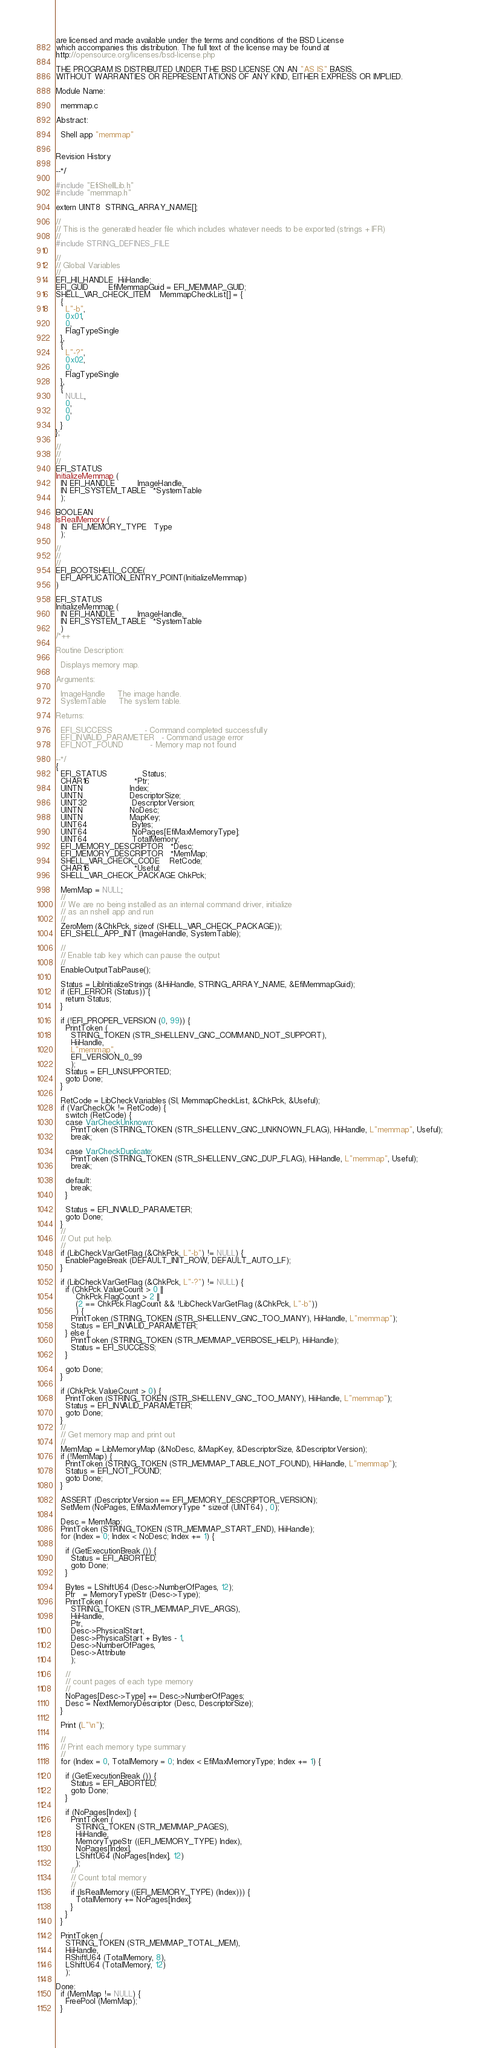Convert code to text. <code><loc_0><loc_0><loc_500><loc_500><_C_>are licensed and made available under the terms and conditions of the BSD License         
which accompanies this distribution. The full text of the license may be found at         
http://opensource.org/licenses/bsd-license.php                                            
                                                                                          
THE PROGRAM IS DISTRIBUTED UNDER THE BSD LICENSE ON AN "AS IS" BASIS,                     
WITHOUT WARRANTIES OR REPRESENTATIONS OF ANY KIND, EITHER EXPRESS OR IMPLIED.             

Module Name: 

  memmap.c
  
Abstract:

  Shell app "memmap"


Revision History

--*/

#include "EfiShellLib.h"
#include "memmap.h"

extern UINT8  STRING_ARRAY_NAME[];

//
// This is the generated header file which includes whatever needs to be exported (strings + IFR)
//
#include STRING_DEFINES_FILE

//
// Global Variables
//
EFI_HII_HANDLE  HiiHandle;
EFI_GUID        EfiMemmapGuid = EFI_MEMMAP_GUID;
SHELL_VAR_CHECK_ITEM    MemmapCheckList[] = {
  {
    L"-b",
    0x01,
    0,
    FlagTypeSingle
  },
  {
    L"-?",
    0x02,
    0,
    FlagTypeSingle
  },
  {
    NULL,
    0,
    0,
    0
  }
};

//
//
//
EFI_STATUS
InitializeMemmap (
  IN EFI_HANDLE         ImageHandle,
  IN EFI_SYSTEM_TABLE   *SystemTable
  );

BOOLEAN
IsRealMemory (
  IN  EFI_MEMORY_TYPE   Type
  );

//
//
//
EFI_BOOTSHELL_CODE(
  EFI_APPLICATION_ENTRY_POINT(InitializeMemmap)
)

EFI_STATUS
InitializeMemmap (
  IN EFI_HANDLE         ImageHandle,
  IN EFI_SYSTEM_TABLE   *SystemTable
  )
/*++

Routine Description:

  Displays memory map.

Arguments:

  ImageHandle     The image handle. 
  SystemTable     The system table.

Returns:

  EFI_SUCCESS             - Command completed successfully
  EFI_INVALID_PARAMETER   - Command usage error
  EFI_NOT_FOUND           - Memory map not found

--*/
{
  EFI_STATUS              Status;
  CHAR16                  *Ptr;
  UINTN                   Index;
  UINTN                   DescriptorSize;
  UINT32                  DescriptorVersion;
  UINTN                   NoDesc;
  UINTN                   MapKey;
  UINT64                  Bytes;
  UINT64                  NoPages[EfiMaxMemoryType];
  UINT64                  TotalMemory;
  EFI_MEMORY_DESCRIPTOR   *Desc;
  EFI_MEMORY_DESCRIPTOR   *MemMap;
  SHELL_VAR_CHECK_CODE    RetCode;
  CHAR16                  *Useful;
  SHELL_VAR_CHECK_PACKAGE ChkPck;

  MemMap = NULL;
  //
  // We are no being installed as an internal command driver, initialize
  // as an nshell app and run
  //
  ZeroMem (&ChkPck, sizeof (SHELL_VAR_CHECK_PACKAGE));
  EFI_SHELL_APP_INIT (ImageHandle, SystemTable);
  
  //
  // Enable tab key which can pause the output
  //
  EnableOutputTabPause();

  Status = LibInitializeStrings (&HiiHandle, STRING_ARRAY_NAME, &EfiMemmapGuid);
  if (EFI_ERROR (Status)) {
    return Status;
  }

  if (!EFI_PROPER_VERSION (0, 99)) {
    PrintToken (
      STRING_TOKEN (STR_SHELLENV_GNC_COMMAND_NOT_SUPPORT),
      HiiHandle,
      L"memmap",
      EFI_VERSION_0_99 
      );
    Status = EFI_UNSUPPORTED;
    goto Done;
  }

  RetCode = LibCheckVariables (SI, MemmapCheckList, &ChkPck, &Useful);
  if (VarCheckOk != RetCode) {
    switch (RetCode) {
    case VarCheckUnknown:
      PrintToken (STRING_TOKEN (STR_SHELLENV_GNC_UNKNOWN_FLAG), HiiHandle, L"memmap", Useful);
      break;

    case VarCheckDuplicate:
      PrintToken (STRING_TOKEN (STR_SHELLENV_GNC_DUP_FLAG), HiiHandle, L"memmap", Useful);
      break;

    default:
      break;
    }

    Status = EFI_INVALID_PARAMETER;
    goto Done;
  }
  //
  // Out put help.
  //
  if (LibCheckVarGetFlag (&ChkPck, L"-b") != NULL) {
    EnablePageBreak (DEFAULT_INIT_ROW, DEFAULT_AUTO_LF);
  }

  if (LibCheckVarGetFlag (&ChkPck, L"-?") != NULL) {
    if (ChkPck.ValueCount > 0 ||
        ChkPck.FlagCount > 2 ||
        (2 == ChkPck.FlagCount && !LibCheckVarGetFlag (&ChkPck, L"-b"))
        ) {
      PrintToken (STRING_TOKEN (STR_SHELLENV_GNC_TOO_MANY), HiiHandle, L"memmap");
      Status = EFI_INVALID_PARAMETER;
    } else {
      PrintToken (STRING_TOKEN (STR_MEMMAP_VERBOSE_HELP), HiiHandle);
      Status = EFI_SUCCESS;
    }

    goto Done;
  }

  if (ChkPck.ValueCount > 0) {
    PrintToken (STRING_TOKEN (STR_SHELLENV_GNC_TOO_MANY), HiiHandle, L"memmap");
    Status = EFI_INVALID_PARAMETER;
    goto Done;
  }
  //
  // Get memory map and print out
  //
  MemMap = LibMemoryMap (&NoDesc, &MapKey, &DescriptorSize, &DescriptorVersion);
  if (!MemMap) {
    PrintToken (STRING_TOKEN (STR_MEMMAP_TABLE_NOT_FOUND), HiiHandle, L"memmap");
    Status = EFI_NOT_FOUND;
    goto Done;
  }

  ASSERT (DescriptorVersion == EFI_MEMORY_DESCRIPTOR_VERSION);
  SetMem (NoPages, EfiMaxMemoryType * sizeof (UINT64) , 0);

  Desc = MemMap;
  PrintToken (STRING_TOKEN (STR_MEMMAP_START_END), HiiHandle);
  for (Index = 0; Index < NoDesc; Index += 1) {

    if (GetExecutionBreak ()) {
      Status = EFI_ABORTED;
      goto Done;
    }

    Bytes = LShiftU64 (Desc->NumberOfPages, 12);
    Ptr   = MemoryTypeStr (Desc->Type);
    PrintToken (
      STRING_TOKEN (STR_MEMMAP_FIVE_ARGS),
      HiiHandle,
      Ptr,
      Desc->PhysicalStart,
      Desc->PhysicalStart + Bytes - 1,
      Desc->NumberOfPages,
      Desc->Attribute
      );

    //
    // count pages of each type memory
    //
    NoPages[Desc->Type] += Desc->NumberOfPages;
    Desc = NextMemoryDescriptor (Desc, DescriptorSize);
  }

  Print (L"\n");

  //
  // Print each memory type summary
  //
  for (Index = 0, TotalMemory = 0; Index < EfiMaxMemoryType; Index += 1) {

    if (GetExecutionBreak ()) {
      Status = EFI_ABORTED;
      goto Done;
    }

    if (NoPages[Index]) {
      PrintToken (
        STRING_TOKEN (STR_MEMMAP_PAGES),
        HiiHandle,
        MemoryTypeStr ((EFI_MEMORY_TYPE) Index),
        NoPages[Index],
        LShiftU64 (NoPages[Index], 12)
        );
      //
      // Count total memory
      //
      if (IsRealMemory ((EFI_MEMORY_TYPE) (Index))) {
        TotalMemory += NoPages[Index];
      }
    }
  }

  PrintToken (
    STRING_TOKEN (STR_MEMMAP_TOTAL_MEM),
    HiiHandle,
    RShiftU64 (TotalMemory, 8),
    LShiftU64 (TotalMemory, 12)
    );

Done:
  if (MemMap != NULL) {
    FreePool (MemMap);
  }
</code> 